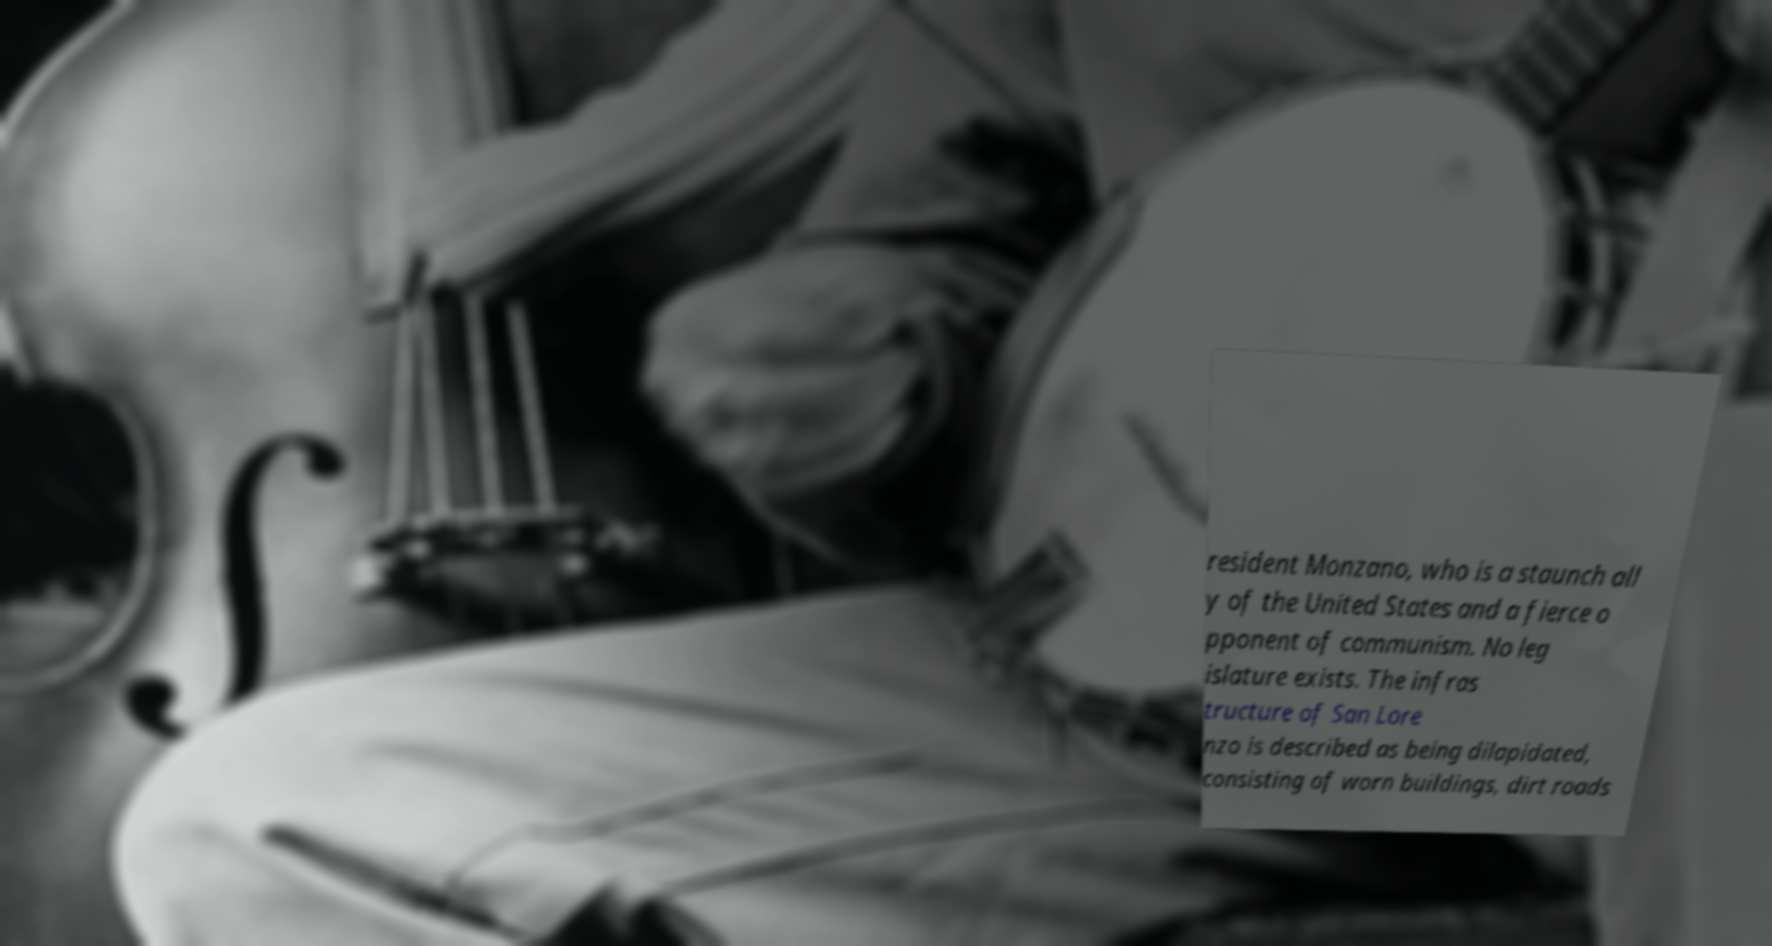For documentation purposes, I need the text within this image transcribed. Could you provide that? resident Monzano, who is a staunch all y of the United States and a fierce o pponent of communism. No leg islature exists. The infras tructure of San Lore nzo is described as being dilapidated, consisting of worn buildings, dirt roads 